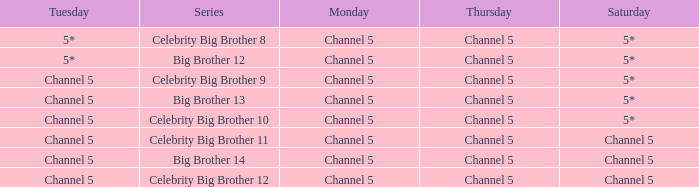Which series airs Saturday on Channel 5? Celebrity Big Brother 11, Big Brother 14, Celebrity Big Brother 12. 